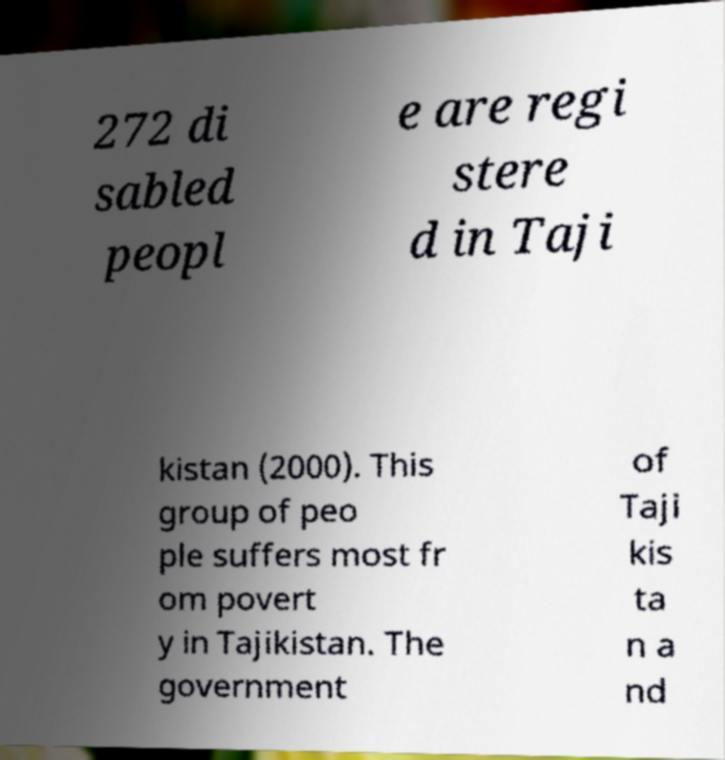Can you read and provide the text displayed in the image?This photo seems to have some interesting text. Can you extract and type it out for me? 272 di sabled peopl e are regi stere d in Taji kistan (2000). This group of peo ple suffers most fr om povert y in Tajikistan. The government of Taji kis ta n a nd 